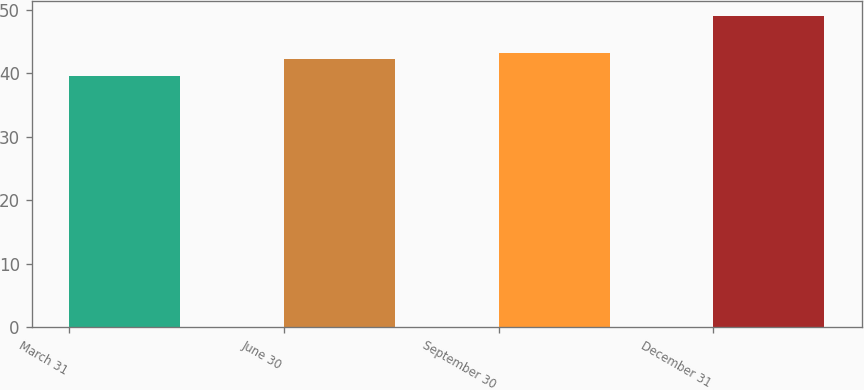Convert chart. <chart><loc_0><loc_0><loc_500><loc_500><bar_chart><fcel>March 31<fcel>June 30<fcel>September 30<fcel>December 31<nl><fcel>39.52<fcel>42.19<fcel>43.14<fcel>48.95<nl></chart> 